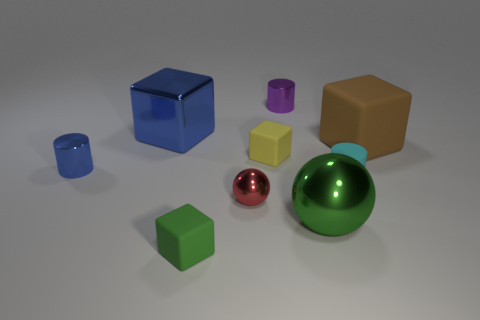Subtract 2 cubes. How many cubes are left? 2 Subtract all green blocks. How many blocks are left? 3 Subtract all metallic cylinders. How many cylinders are left? 1 Subtract 0 cyan blocks. How many objects are left? 9 Subtract all balls. How many objects are left? 7 Subtract all cyan cubes. Subtract all blue spheres. How many cubes are left? 4 Subtract all yellow cubes. How many blue cylinders are left? 1 Subtract all blue matte spheres. Subtract all blue cylinders. How many objects are left? 8 Add 5 tiny blue metal cylinders. How many tiny blue metal cylinders are left? 6 Add 4 tiny yellow blocks. How many tiny yellow blocks exist? 5 